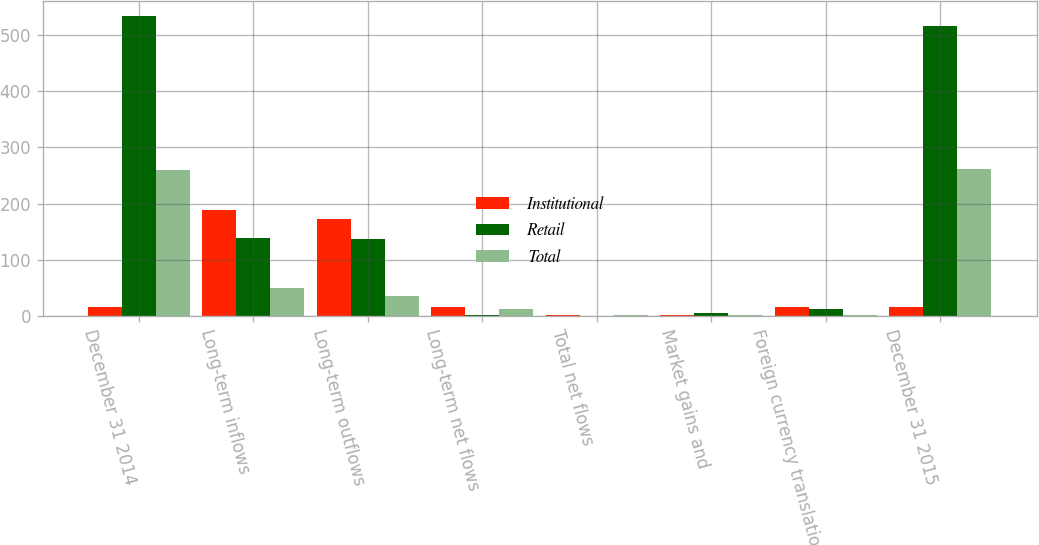<chart> <loc_0><loc_0><loc_500><loc_500><stacked_bar_chart><ecel><fcel>December 31 2014<fcel>Long-term inflows<fcel>Long-term outflows<fcel>Long-term net flows<fcel>Total net flows<fcel>Market gains and<fcel>Foreign currency translation<fcel>December 31 2015<nl><fcel>Institutional<fcel>16.1<fcel>189.1<fcel>172.9<fcel>16.2<fcel>2.5<fcel>2.6<fcel>16<fcel>16.1<nl><fcel>Retail<fcel>532.5<fcel>139.1<fcel>136.3<fcel>2.8<fcel>1<fcel>4.7<fcel>13.3<fcel>514.8<nl><fcel>Total<fcel>259.9<fcel>50<fcel>36.6<fcel>13.4<fcel>1.5<fcel>2.1<fcel>2.7<fcel>260.8<nl></chart> 